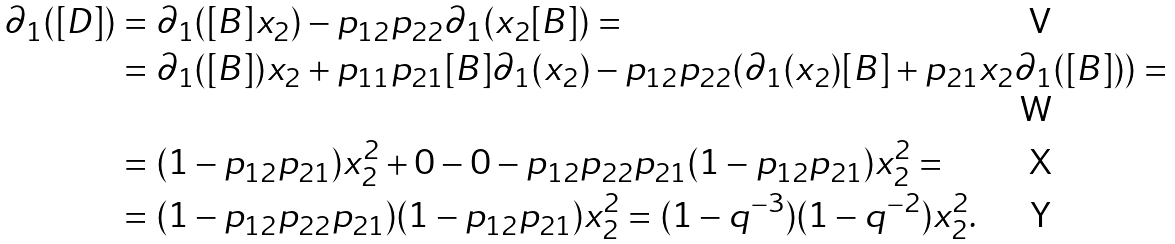Convert formula to latex. <formula><loc_0><loc_0><loc_500><loc_500>\partial _ { 1 } ( [ D ] ) & = \partial _ { 1 } ( [ B ] x _ { 2 } ) - p _ { 1 2 } p _ { 2 2 } \partial _ { 1 } ( x _ { 2 } [ B ] ) = \\ & = \partial _ { 1 } ( [ B ] ) x _ { 2 } + p _ { 1 1 } p _ { 2 1 } [ B ] \partial _ { 1 } ( x _ { 2 } ) - p _ { 1 2 } p _ { 2 2 } ( \partial _ { 1 } ( x _ { 2 } ) [ B ] + p _ { 2 1 } x _ { 2 } \partial _ { 1 } ( [ B ] ) ) = \\ & = ( 1 - p _ { 1 2 } p _ { 2 1 } ) x _ { 2 } ^ { 2 } + 0 - 0 - p _ { 1 2 } p _ { 2 2 } p _ { 2 1 } ( 1 - p _ { 1 2 } p _ { 2 1 } ) x _ { 2 } ^ { 2 } = \\ & = ( 1 - p _ { 1 2 } p _ { 2 2 } p _ { 2 1 } ) ( 1 - p _ { 1 2 } p _ { 2 1 } ) x _ { 2 } ^ { 2 } = ( 1 - q ^ { - 3 } ) ( 1 - q ^ { - 2 } ) x _ { 2 } ^ { 2 } .</formula> 